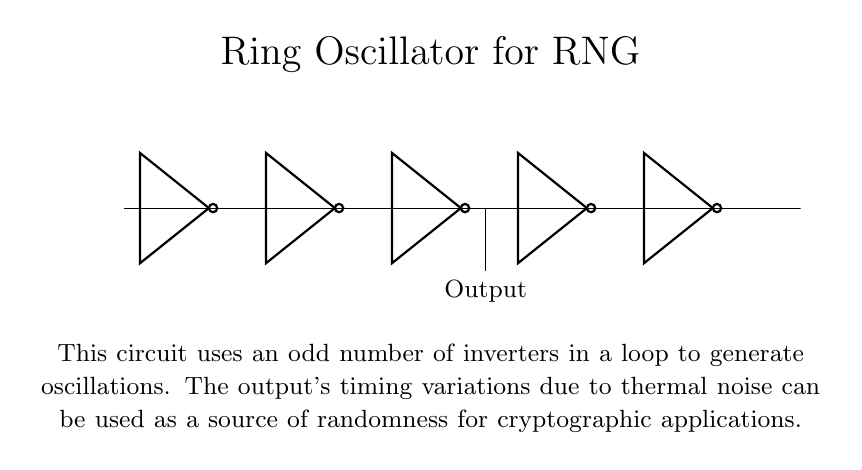What is the number of inverters in this circuit? The circuit diagram shows five inverters positioned in a loop. Each inverter is connected sequentially, forming the complete ring oscillator.
Answer: five What is the purpose of the output taken from this circuit? The output of the ring oscillator is obtained from the middle inverter, indicating it can generate oscillations. These oscillations are subject to timing variations, which are used as entropy for random number generation in cryptography.
Answer: random number generation What type of oscillator does this circuit represent? The circuit is a type of oscillator formed by an odd number of inverters connected in series, creating a feedback loop necessary for generating oscillations.
Answer: ring oscillator Which inverter is the output derived from? The output is taken from the third inverter in the series, as indicated by its connection downwards to the output node in the diagram.
Answer: third inverter How does thermal noise contribute to the functioning of this circuit? Thermal noise affects the timing of the output signal generated from the oscillations of the inverters, introducing randomness that can be utilized for secure cryptographic applications.
Answer: by introducing randomness Why does the circuit require an odd number of inverters? An odd number of inverters ensures that the circuit provides positive feedback, which is essential for sustaining oscillations. If there were an even number, the feedback would be negative, preventing the oscillation.
Answer: to maintain oscillations 